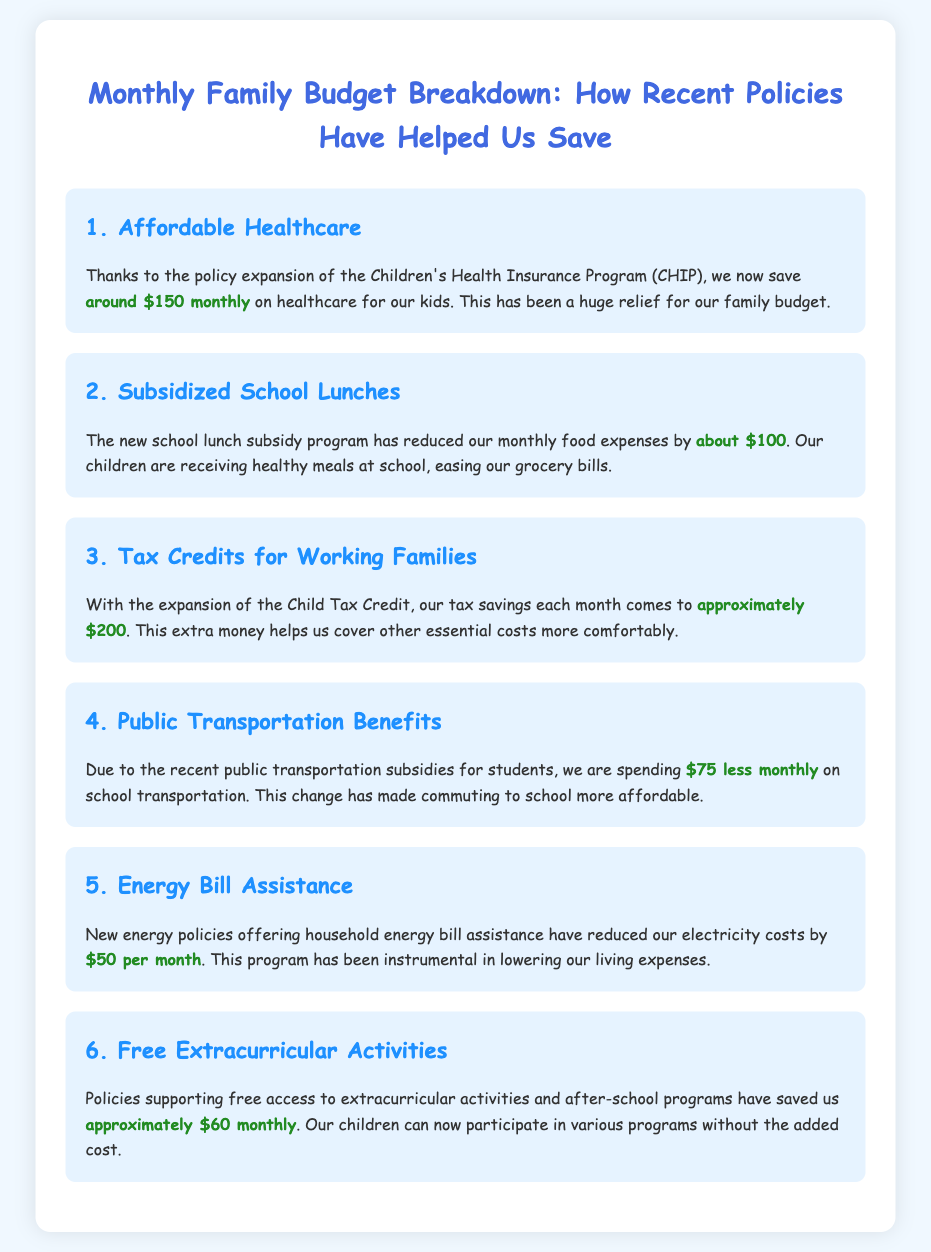What is the monthly savings from the Children's Health Insurance Program? The document states that the savings from CHIP is around $150 monthly.
Answer: $150 How much do we save on school lunches? The document mentions that the new school lunch subsidy program has reduced food expenses by about $100.
Answer: $100 What is the total monthly saving from the Child Tax Credit? The document indicates that the expansion of the Child Tax Credit results in approximately $200 in savings each month.
Answer: $200 How much are we saving on school transportation? According to the document, the public transportation subsidies have helped us spend $75 less monthly on transportation.
Answer: $75 What is the amount saved from energy bill assistance? The document describes that new energy policies have reduced our electricity costs by $50 per month.
Answer: $50 What is the total monthly saving from free extracurricular activities? The document states that free access to extracurricular activities has saved us approximately $60 monthly.
Answer: $60 Which policy provides savings of around $150 monthly? The document refers to the Children's Health Insurance Program (CHIP) for this savings amount.
Answer: CHIP Which program helps reduce food expenses at school? The document mentions the new school lunch subsidy program for reducing food expenses.
Answer: School lunch subsidy program What is the primary theme of the document? The document focuses on how recent policies have helped families save money in various areas.
Answer: Savings from policies 